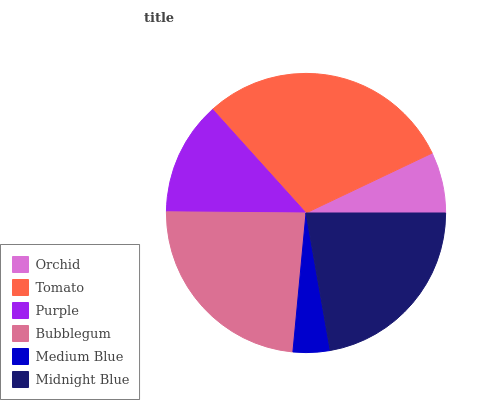Is Medium Blue the minimum?
Answer yes or no. Yes. Is Tomato the maximum?
Answer yes or no. Yes. Is Purple the minimum?
Answer yes or no. No. Is Purple the maximum?
Answer yes or no. No. Is Tomato greater than Purple?
Answer yes or no. Yes. Is Purple less than Tomato?
Answer yes or no. Yes. Is Purple greater than Tomato?
Answer yes or no. No. Is Tomato less than Purple?
Answer yes or no. No. Is Midnight Blue the high median?
Answer yes or no. Yes. Is Purple the low median?
Answer yes or no. Yes. Is Purple the high median?
Answer yes or no. No. Is Tomato the low median?
Answer yes or no. No. 